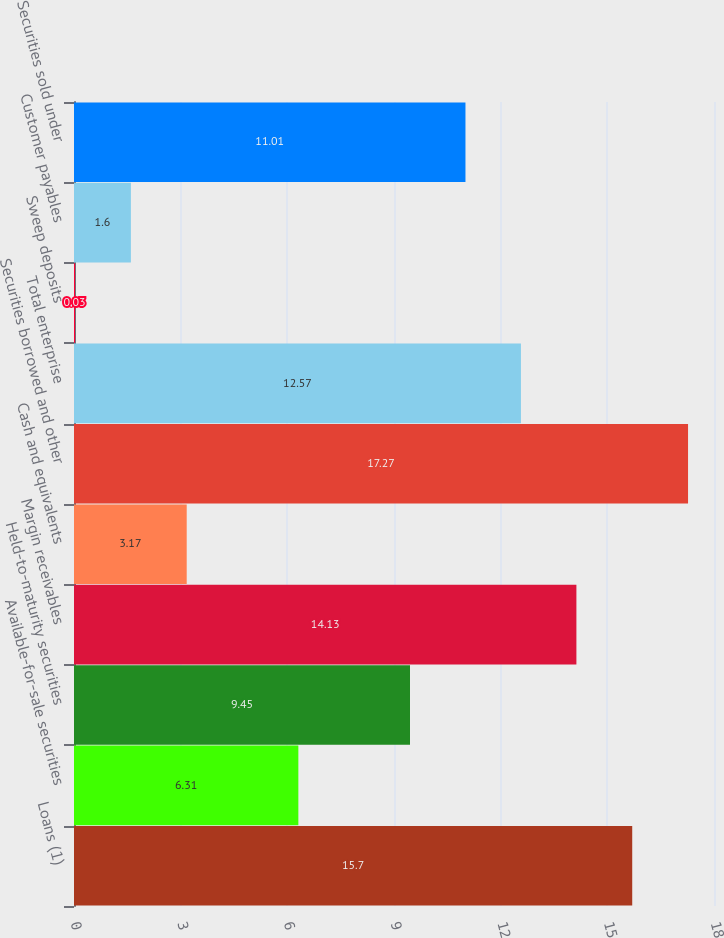<chart> <loc_0><loc_0><loc_500><loc_500><bar_chart><fcel>Loans (1)<fcel>Available-for-sale securities<fcel>Held-to-maturity securities<fcel>Margin receivables<fcel>Cash and equivalents<fcel>Securities borrowed and other<fcel>Total enterprise<fcel>Sweep deposits<fcel>Customer payables<fcel>Securities sold under<nl><fcel>15.7<fcel>6.31<fcel>9.45<fcel>14.13<fcel>3.17<fcel>17.27<fcel>12.57<fcel>0.03<fcel>1.6<fcel>11.01<nl></chart> 